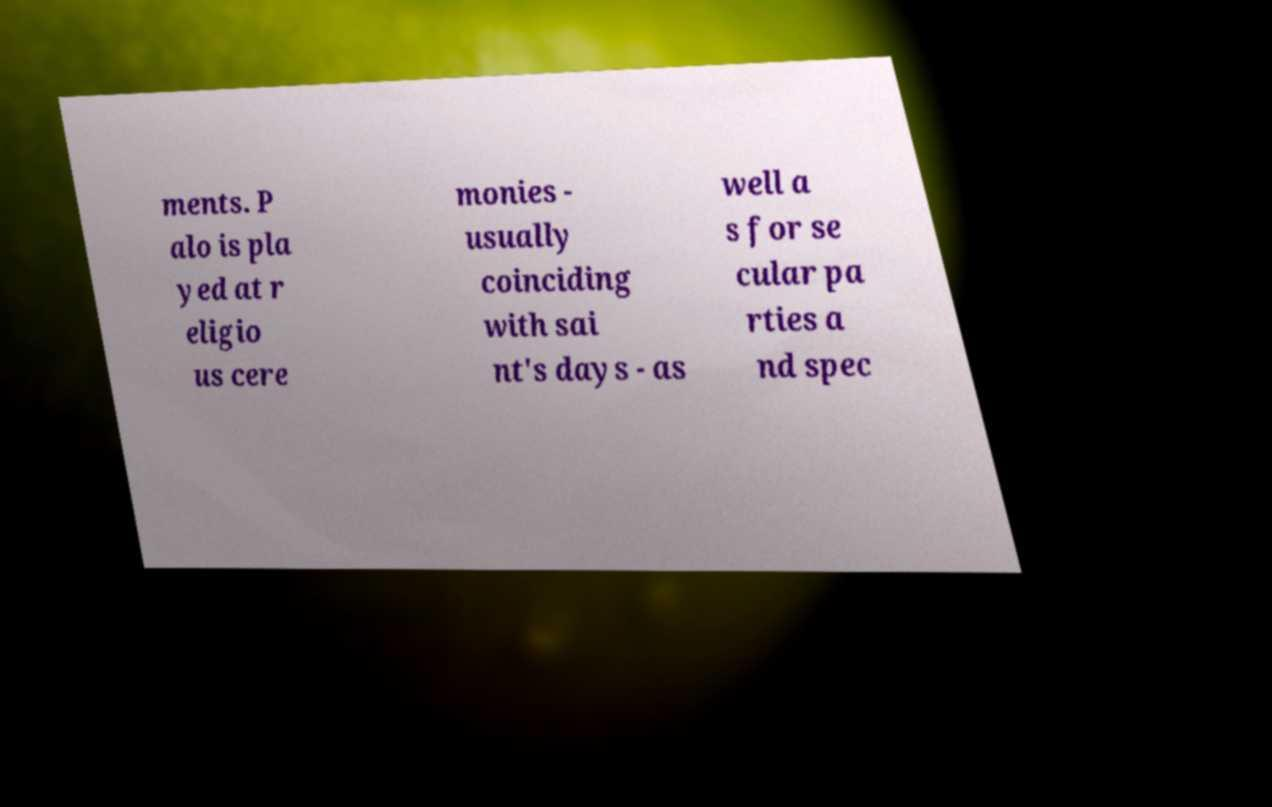Please read and relay the text visible in this image. What does it say? ments. P alo is pla yed at r eligio us cere monies - usually coinciding with sai nt's days - as well a s for se cular pa rties a nd spec 